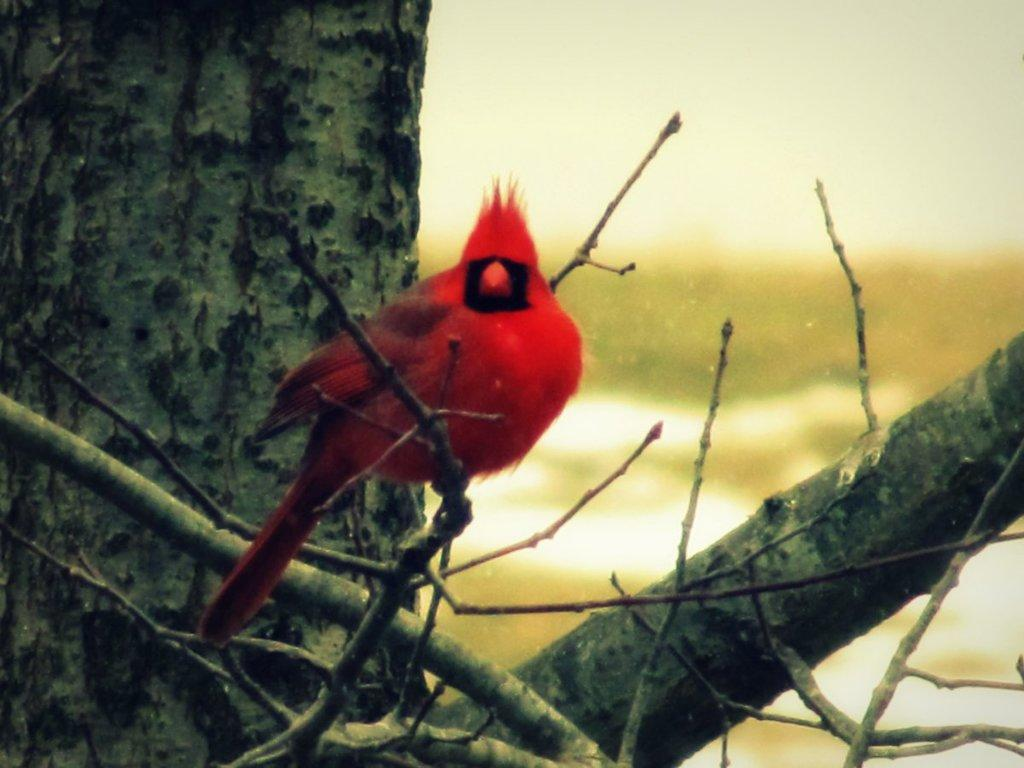What type of animal can be seen in the image? There is a bird in the image. Where is the bird located? The bird is on a branch of a tree. Can you describe the background of the image? The background of the image is blurry. What type of competition is the bird participating in within the image? There is no competition present in the image; it simply shows a bird on a branch of a tree. 